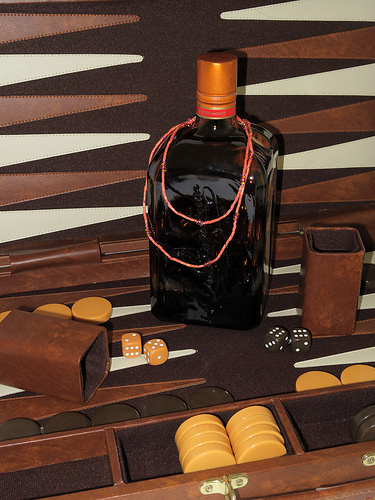<image>
Is there a die in the board? Yes. The die is contained within or inside the board, showing a containment relationship. 